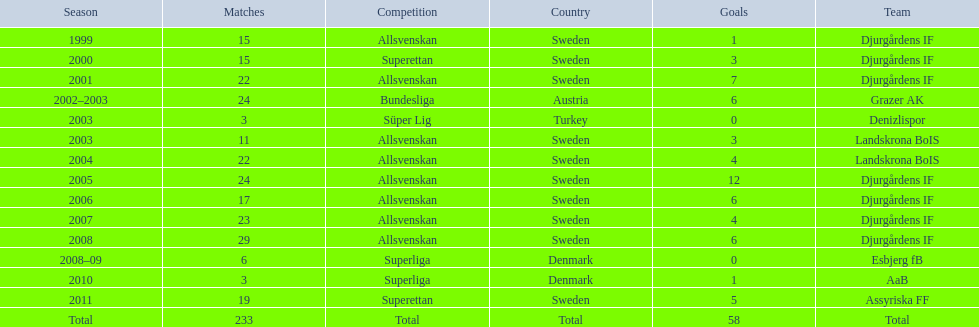In what season are the most goals scored? 2005. 